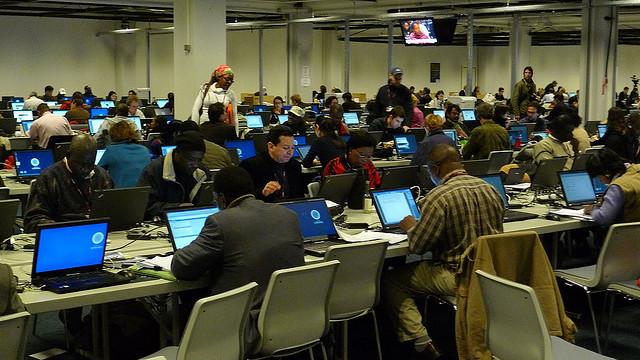How many computers are there?
Write a very short answer. Many. Is this a classroom?
Keep it brief. Yes. How many chairs are not being utilized?
Write a very short answer. 4. How many empty chairs?
Answer briefly. 4. 